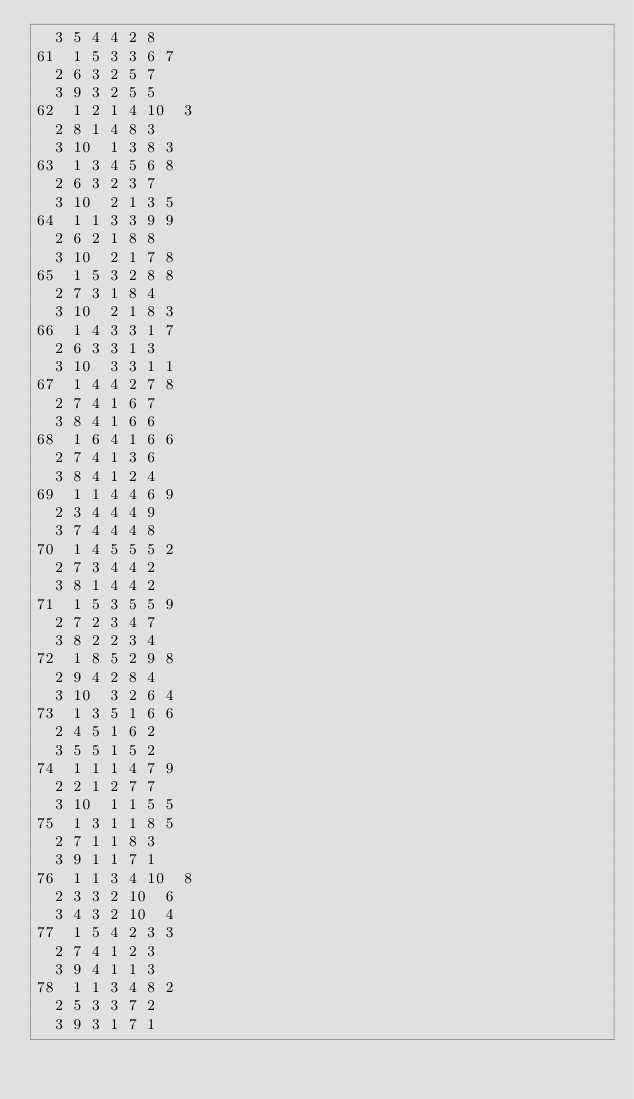Convert code to text. <code><loc_0><loc_0><loc_500><loc_500><_ObjectiveC_>	3	5	4	4	2	8	
61	1	5	3	3	6	7	
	2	6	3	2	5	7	
	3	9	3	2	5	5	
62	1	2	1	4	10	3	
	2	8	1	4	8	3	
	3	10	1	3	8	3	
63	1	3	4	5	6	8	
	2	6	3	2	3	7	
	3	10	2	1	3	5	
64	1	1	3	3	9	9	
	2	6	2	1	8	8	
	3	10	2	1	7	8	
65	1	5	3	2	8	8	
	2	7	3	1	8	4	
	3	10	2	1	8	3	
66	1	4	3	3	1	7	
	2	6	3	3	1	3	
	3	10	3	3	1	1	
67	1	4	4	2	7	8	
	2	7	4	1	6	7	
	3	8	4	1	6	6	
68	1	6	4	1	6	6	
	2	7	4	1	3	6	
	3	8	4	1	2	4	
69	1	1	4	4	6	9	
	2	3	4	4	4	9	
	3	7	4	4	4	8	
70	1	4	5	5	5	2	
	2	7	3	4	4	2	
	3	8	1	4	4	2	
71	1	5	3	5	5	9	
	2	7	2	3	4	7	
	3	8	2	2	3	4	
72	1	8	5	2	9	8	
	2	9	4	2	8	4	
	3	10	3	2	6	4	
73	1	3	5	1	6	6	
	2	4	5	1	6	2	
	3	5	5	1	5	2	
74	1	1	1	4	7	9	
	2	2	1	2	7	7	
	3	10	1	1	5	5	
75	1	3	1	1	8	5	
	2	7	1	1	8	3	
	3	9	1	1	7	1	
76	1	1	3	4	10	8	
	2	3	3	2	10	6	
	3	4	3	2	10	4	
77	1	5	4	2	3	3	
	2	7	4	1	2	3	
	3	9	4	1	1	3	
78	1	1	3	4	8	2	
	2	5	3	3	7	2	
	3	9	3	1	7	1	</code> 